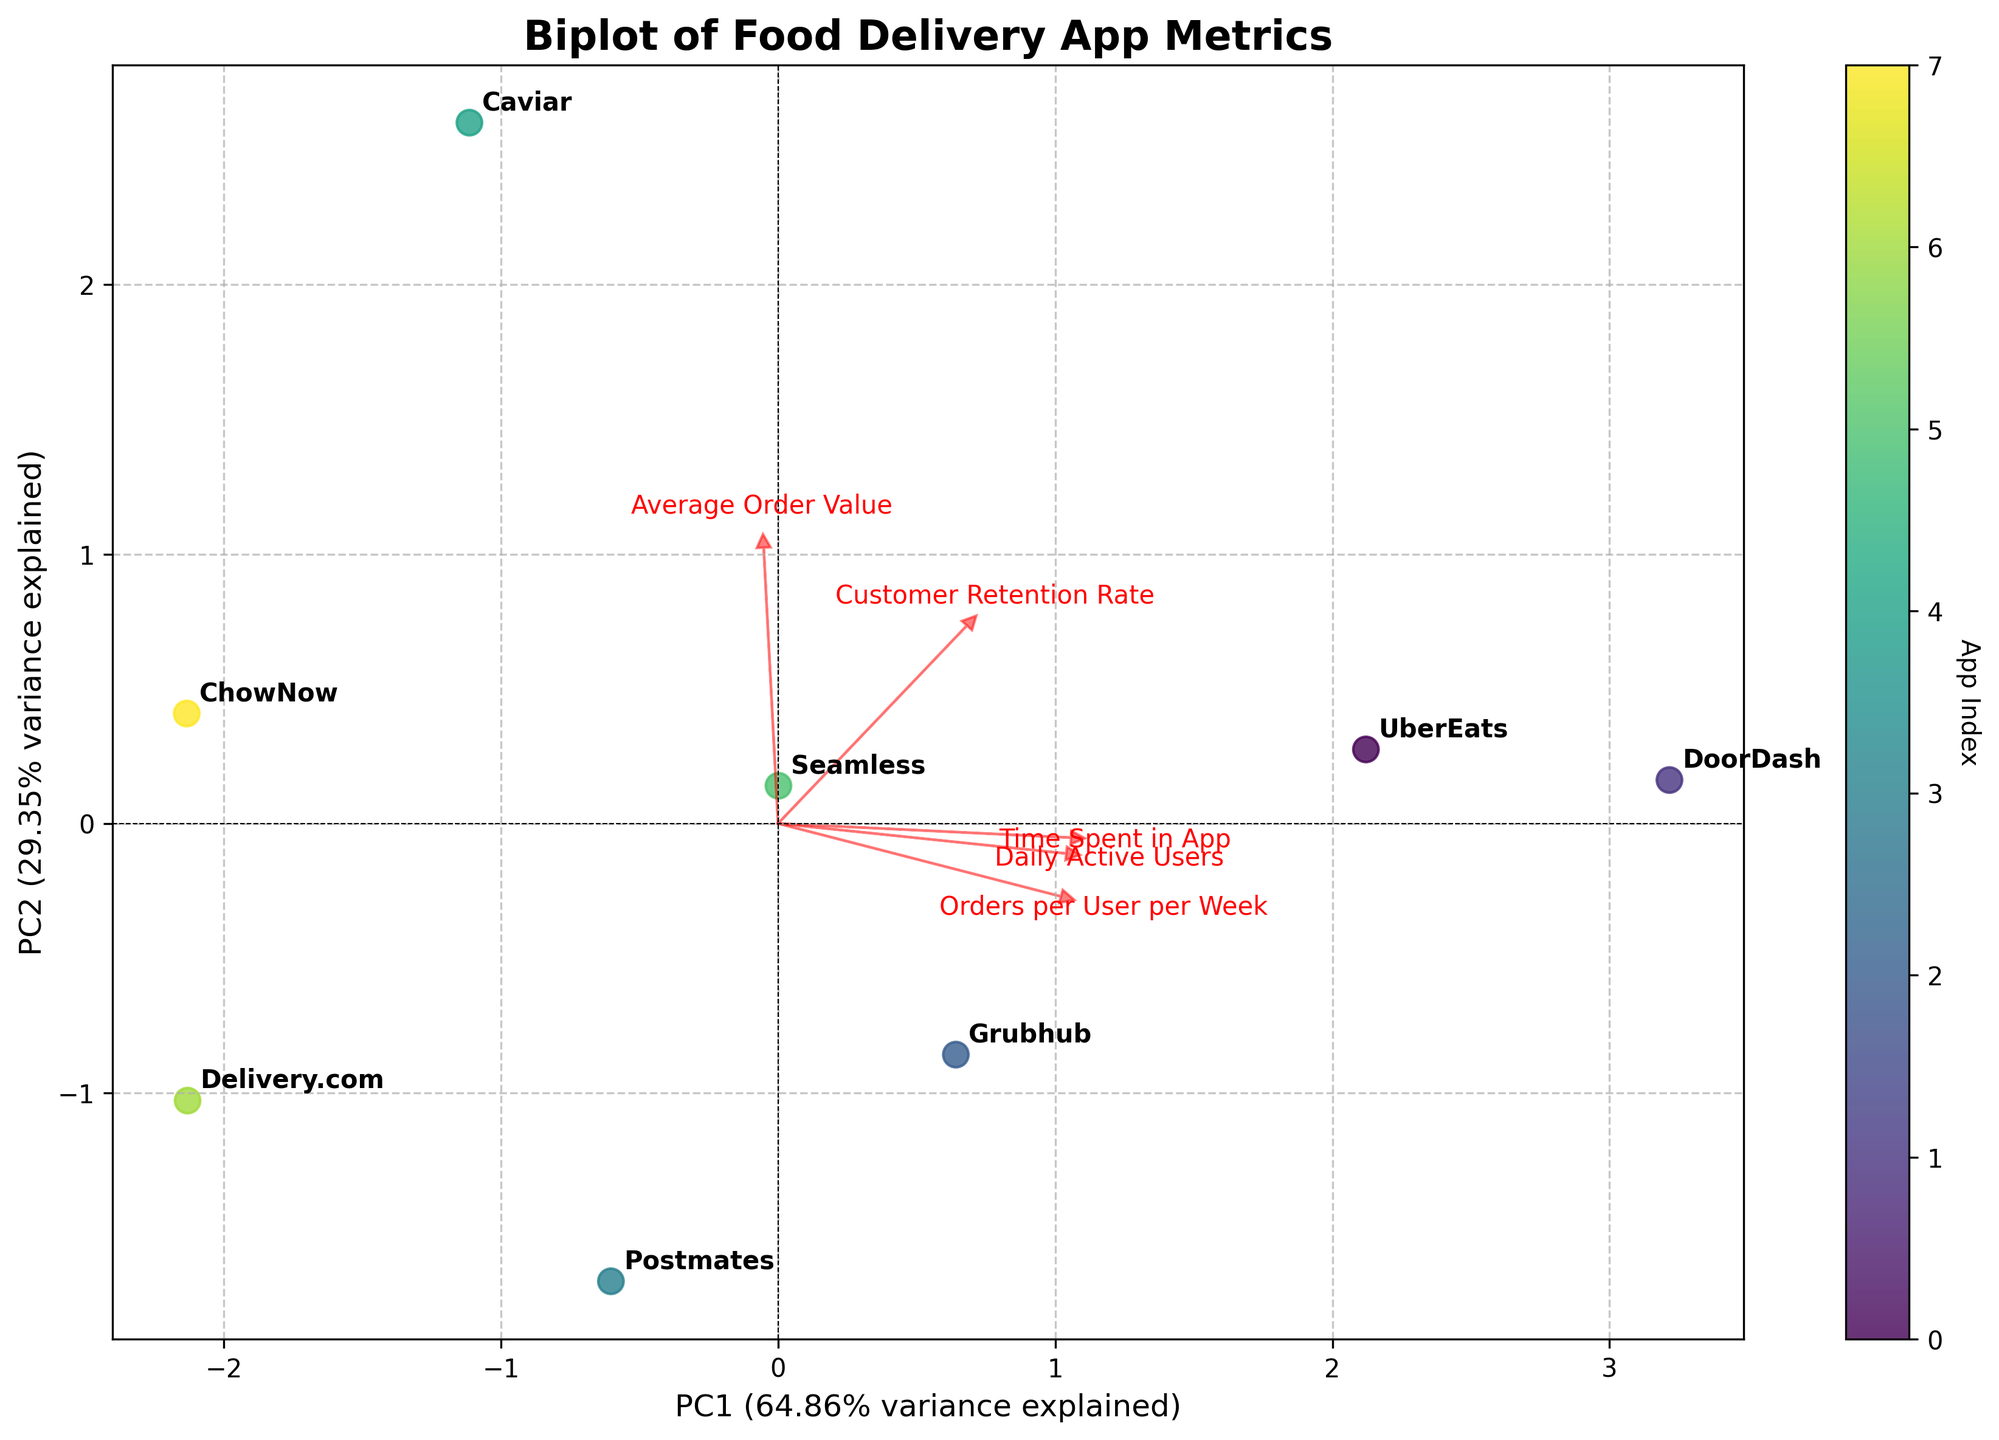What is the title of the figure? The title of the figure is located at the top of the plot. It gives an overview of what the biplot is about.
Answer: Biplot of Food Delivery App Metrics How many food delivery apps are plotted in the biplot? To find out the number of food delivery apps, count the unique labels annotating the data points in the plot.
Answer: 8 Which app appears closest to the origin (0, 0) in the biplot? Identify the data point closest to the intersection of the x-axis and y-axis (the origin).
Answer: Delivery.com Which metric shows the highest loading on the first principal component (PC1)? Loading vectors are represented by arrows. The largest arrow pointing in the x-direction (PC1) indicates the highest loading.
Answer: Daily Active Users What app has the highest value on PC2? Look for the data point located highest along the y-axis (PC2).
Answer: DoorDash Which two metrics have the most similar directions indicated by their loading vectors? Compare the direction and length of the arrows representing loading vectors. The two arrows pointing in similar directions are the most similar.
Answer: Customer Retention Rate and Daily Active Users Does UberEats have a higher or lower PC1 value than Postmates? Locate UberEats and Postmates on the plot and compare their positions on the x-axis (PC1).
Answer: Higher Which app has the lowest combination of Daily Active Users and Orders per User per Week based on the plot? The app located in the lowest direction of the arrows representing 'Daily Active Users' and 'Orders per User per Week' has the lowest combination of these metrics.
Answer: ChowNow How much variance is explained by the first two principal components? The variance explained by PC1 and PC2 is usually provided in the labels of the axes. Sum these two percentages.
Answer: Approximately 70% Which metric contributes most to differentiating Seamless and Caviar based on their PC1 and PC2 values? Look at the loading vectors and identify which metric's direction better separates Seamless and Caviar on the plot.
Answer: Average Order Value 